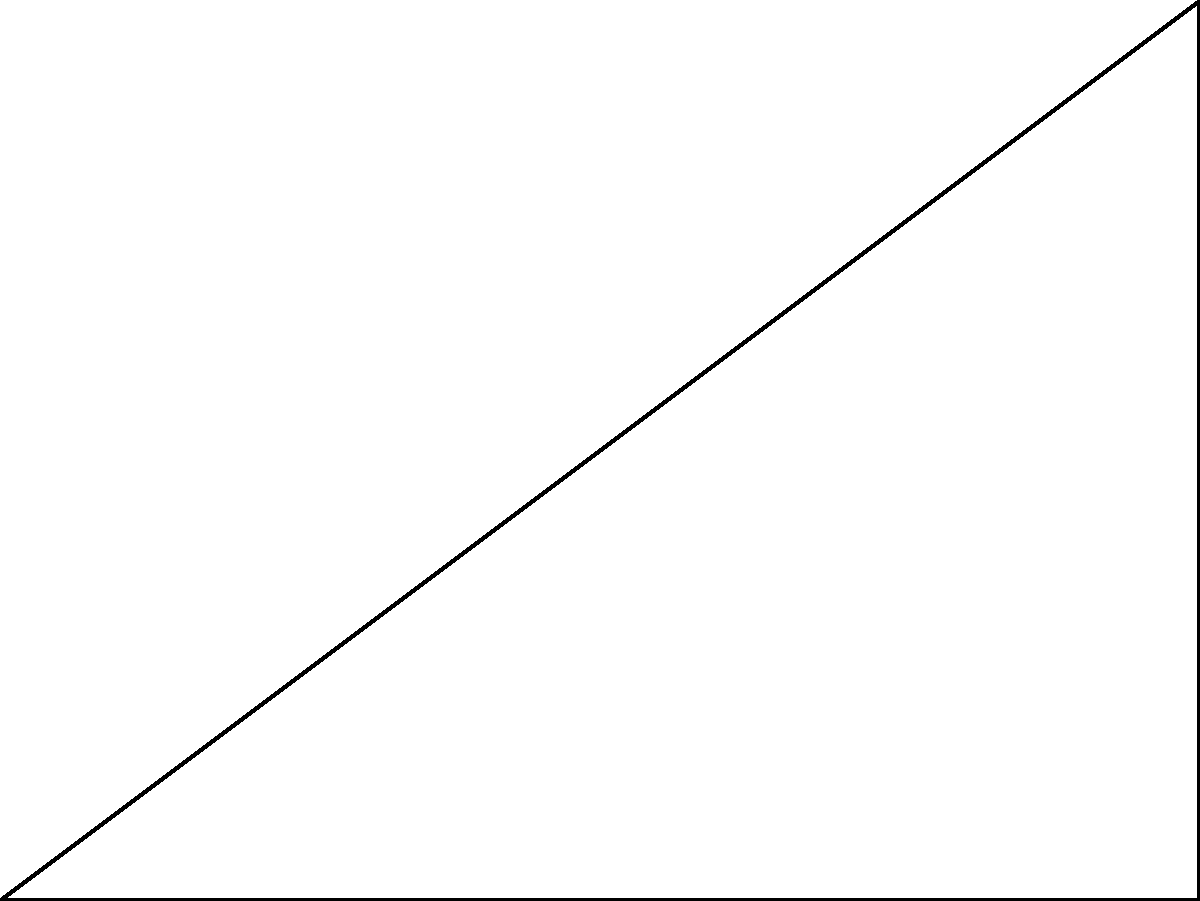In your favorite mobile game, you need to determine the distance between two landmarks on the map. The game uses a grid system where each unit represents 100 meters. You know that from point A to point B is 8 units east, and from point B to point C is 6 units north. What is the direct distance between points A and C in meters? Let's solve this step-by-step using the Pythagorean theorem:

1) We have a right triangle ABC where:
   - The base (AB) is 8 units
   - The height (BC) is 6 units
   - We need to find the hypotenuse (AC)

2) The Pythagorean theorem states: $a^2 + b^2 = c^2$
   Where $c$ is the hypotenuse and $a$ and $b$ are the other two sides.

3) Let's plug in our values:
   $8^2 + 6^2 = c^2$

4) Simplify:
   $64 + 36 = c^2$
   $100 = c^2$

5) Take the square root of both sides:
   $\sqrt{100} = c$
   $10 = c$

6) So, the distance in units is 10.

7) Remember that each unit represents 100 meters, so:
   $10 \times 100 = 1000$ meters

Therefore, the direct distance between points A and C is 1000 meters.
Answer: 1000 meters 